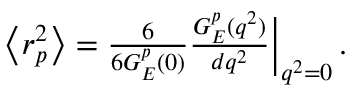Convert formula to latex. <formula><loc_0><loc_0><loc_500><loc_500>\begin{array} { r } { \left < r _ { p } ^ { 2 } \right > = \frac { 6 } { 6 { G _ { E } ^ { p } } ( 0 ) } \frac { G _ { E } ^ { p } ( q ^ { 2 } ) } { d q ^ { 2 } } \Big | _ { q ^ { 2 } = 0 } \, . } \end{array}</formula> 